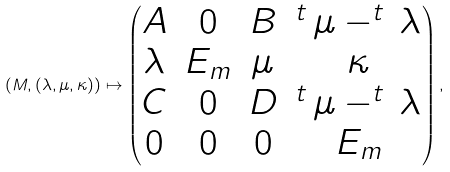Convert formula to latex. <formula><loc_0><loc_0><loc_500><loc_500>( M , ( \lambda , \mu , \kappa ) ) \mapsto \begin{pmatrix} A & 0 & B & ^ { t } \, \mu - ^ { t } \, \lambda \\ \lambda & E _ { m } & \mu & \kappa \\ C & 0 & D & ^ { t } \, \mu - ^ { t } \, \lambda \\ 0 & 0 & 0 & E _ { m } \end{pmatrix} ,</formula> 